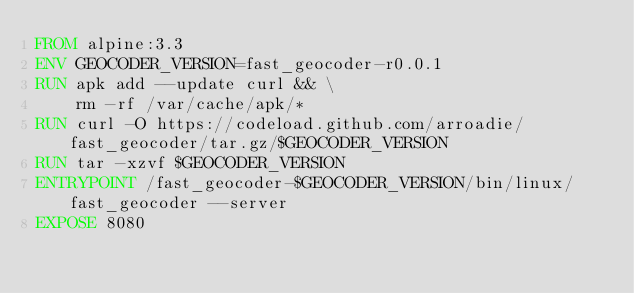Convert code to text. <code><loc_0><loc_0><loc_500><loc_500><_Dockerfile_>FROM alpine:3.3
ENV GEOCODER_VERSION=fast_geocoder-r0.0.1
RUN apk add --update curl && \
    rm -rf /var/cache/apk/*
RUN curl -O https://codeload.github.com/arroadie/fast_geocoder/tar.gz/$GEOCODER_VERSION
RUN tar -xzvf $GEOCODER_VERSION
ENTRYPOINT /fast_geocoder-$GEOCODER_VERSION/bin/linux/fast_geocoder --server
EXPOSE 8080
</code> 